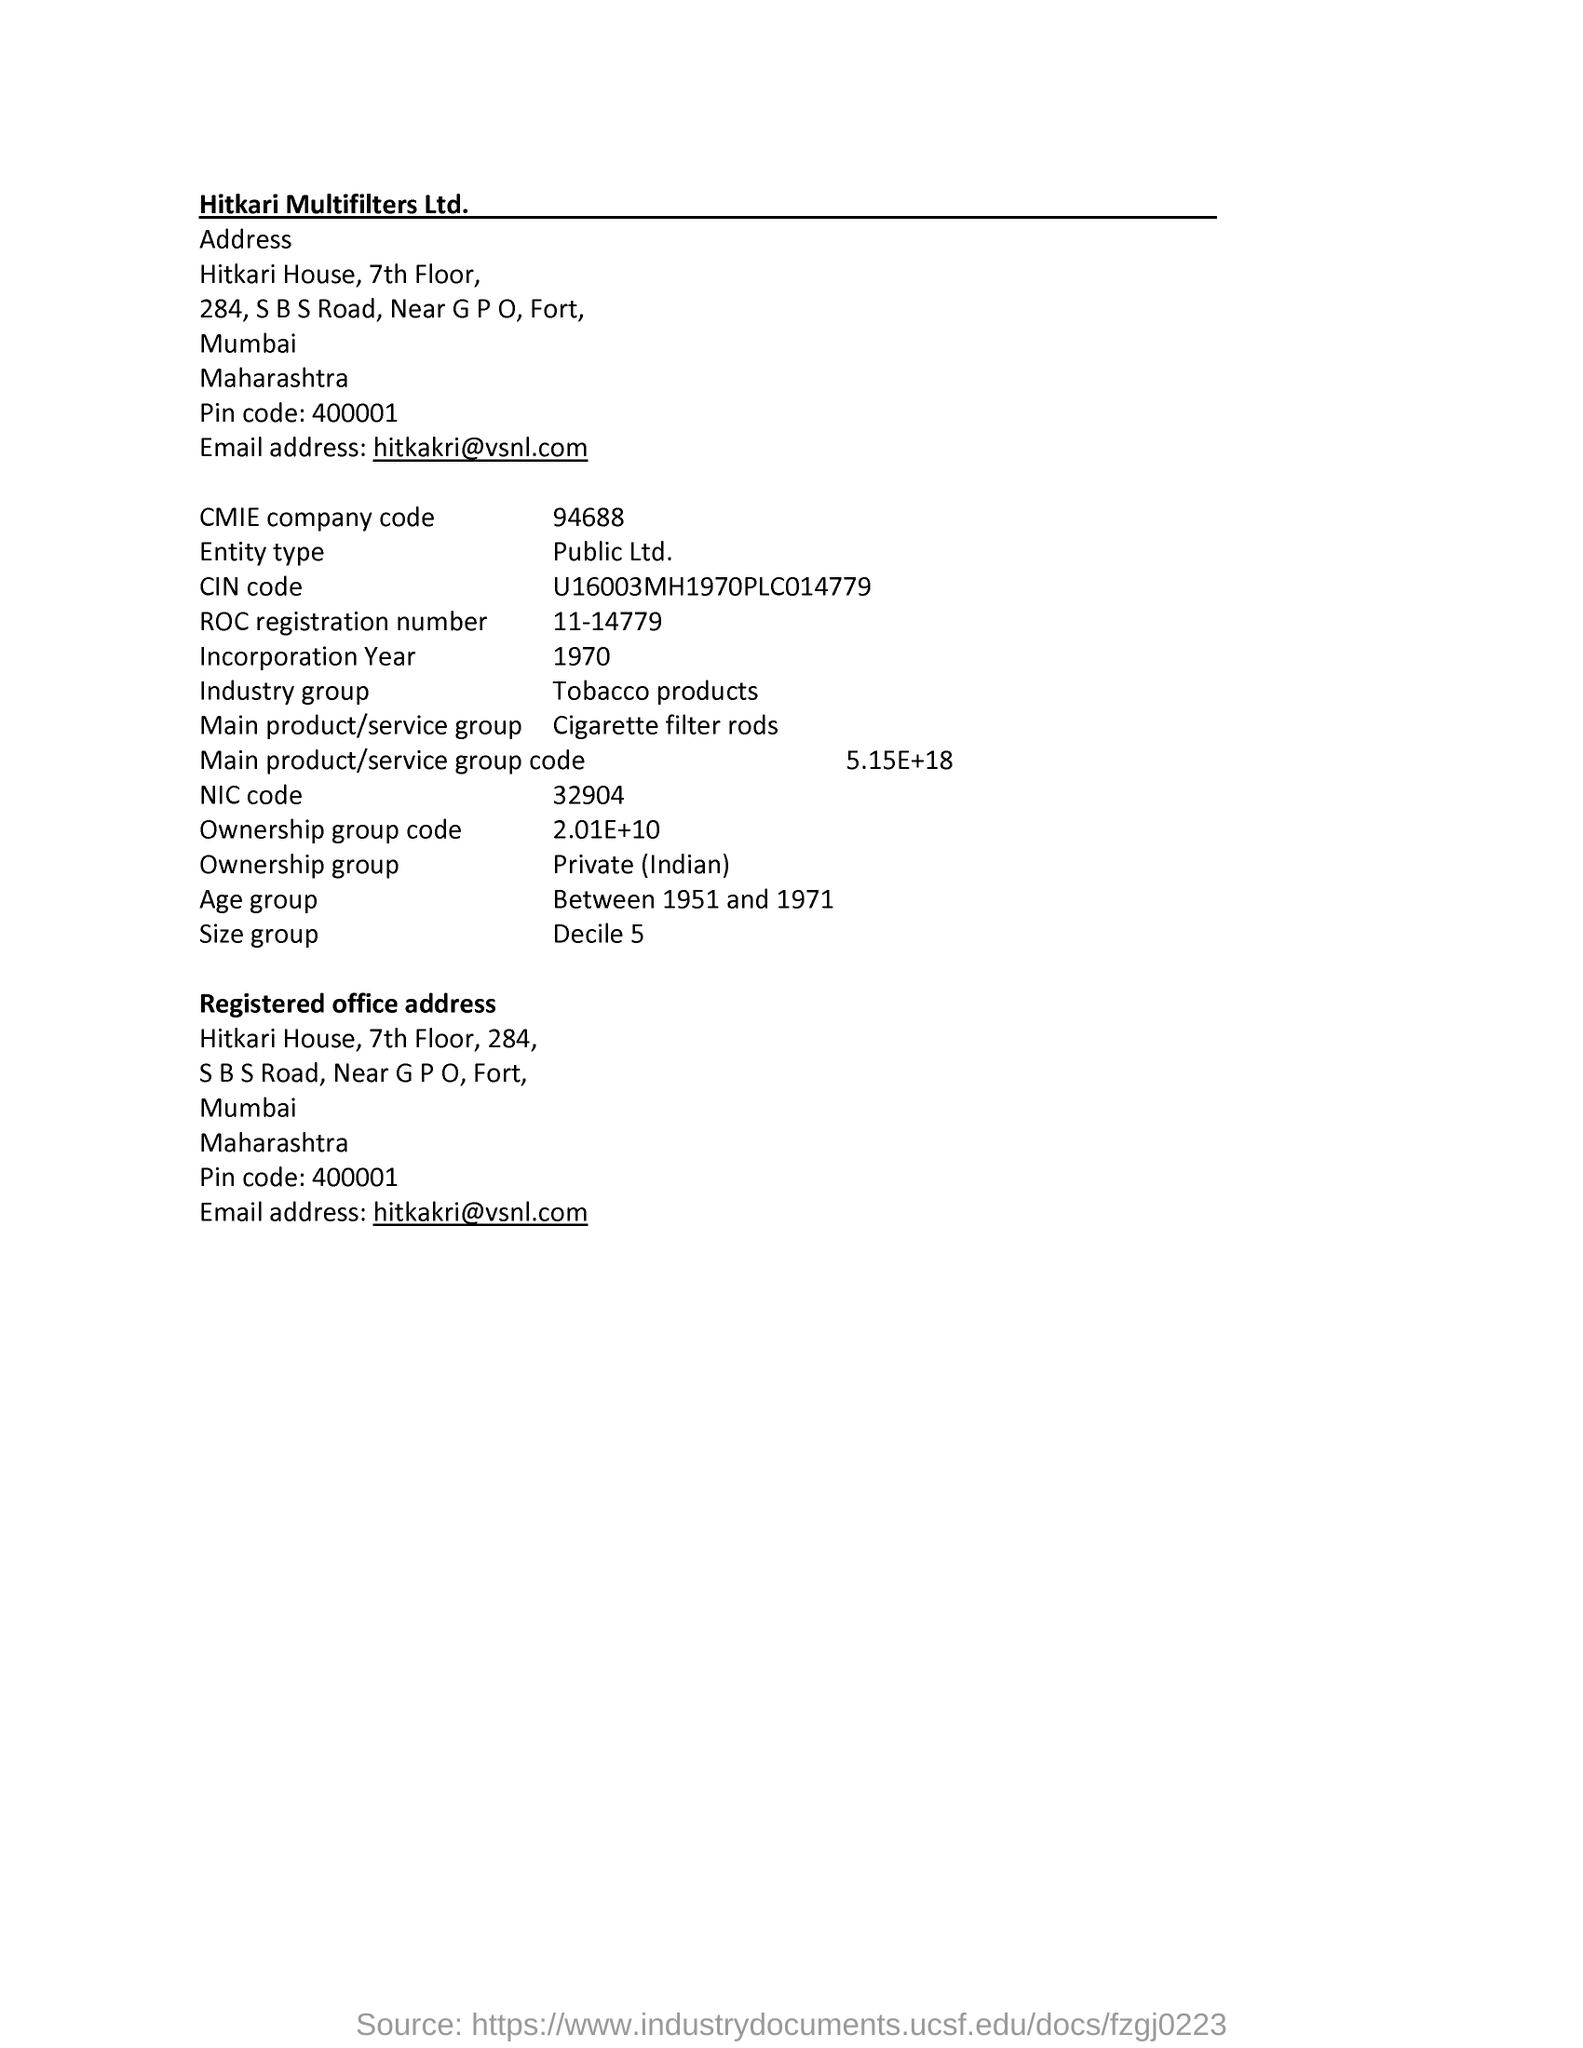What is the name of the oraganisation mentiones in the document?
Offer a terse response. Hitkari multifilters Ltd. What is cmie company code?
Give a very brief answer. 94688. What is roc registration number?
Your answer should be very brief. 11-14779. What does industry group refer to ?
Ensure brevity in your answer.  Tobacco products. 